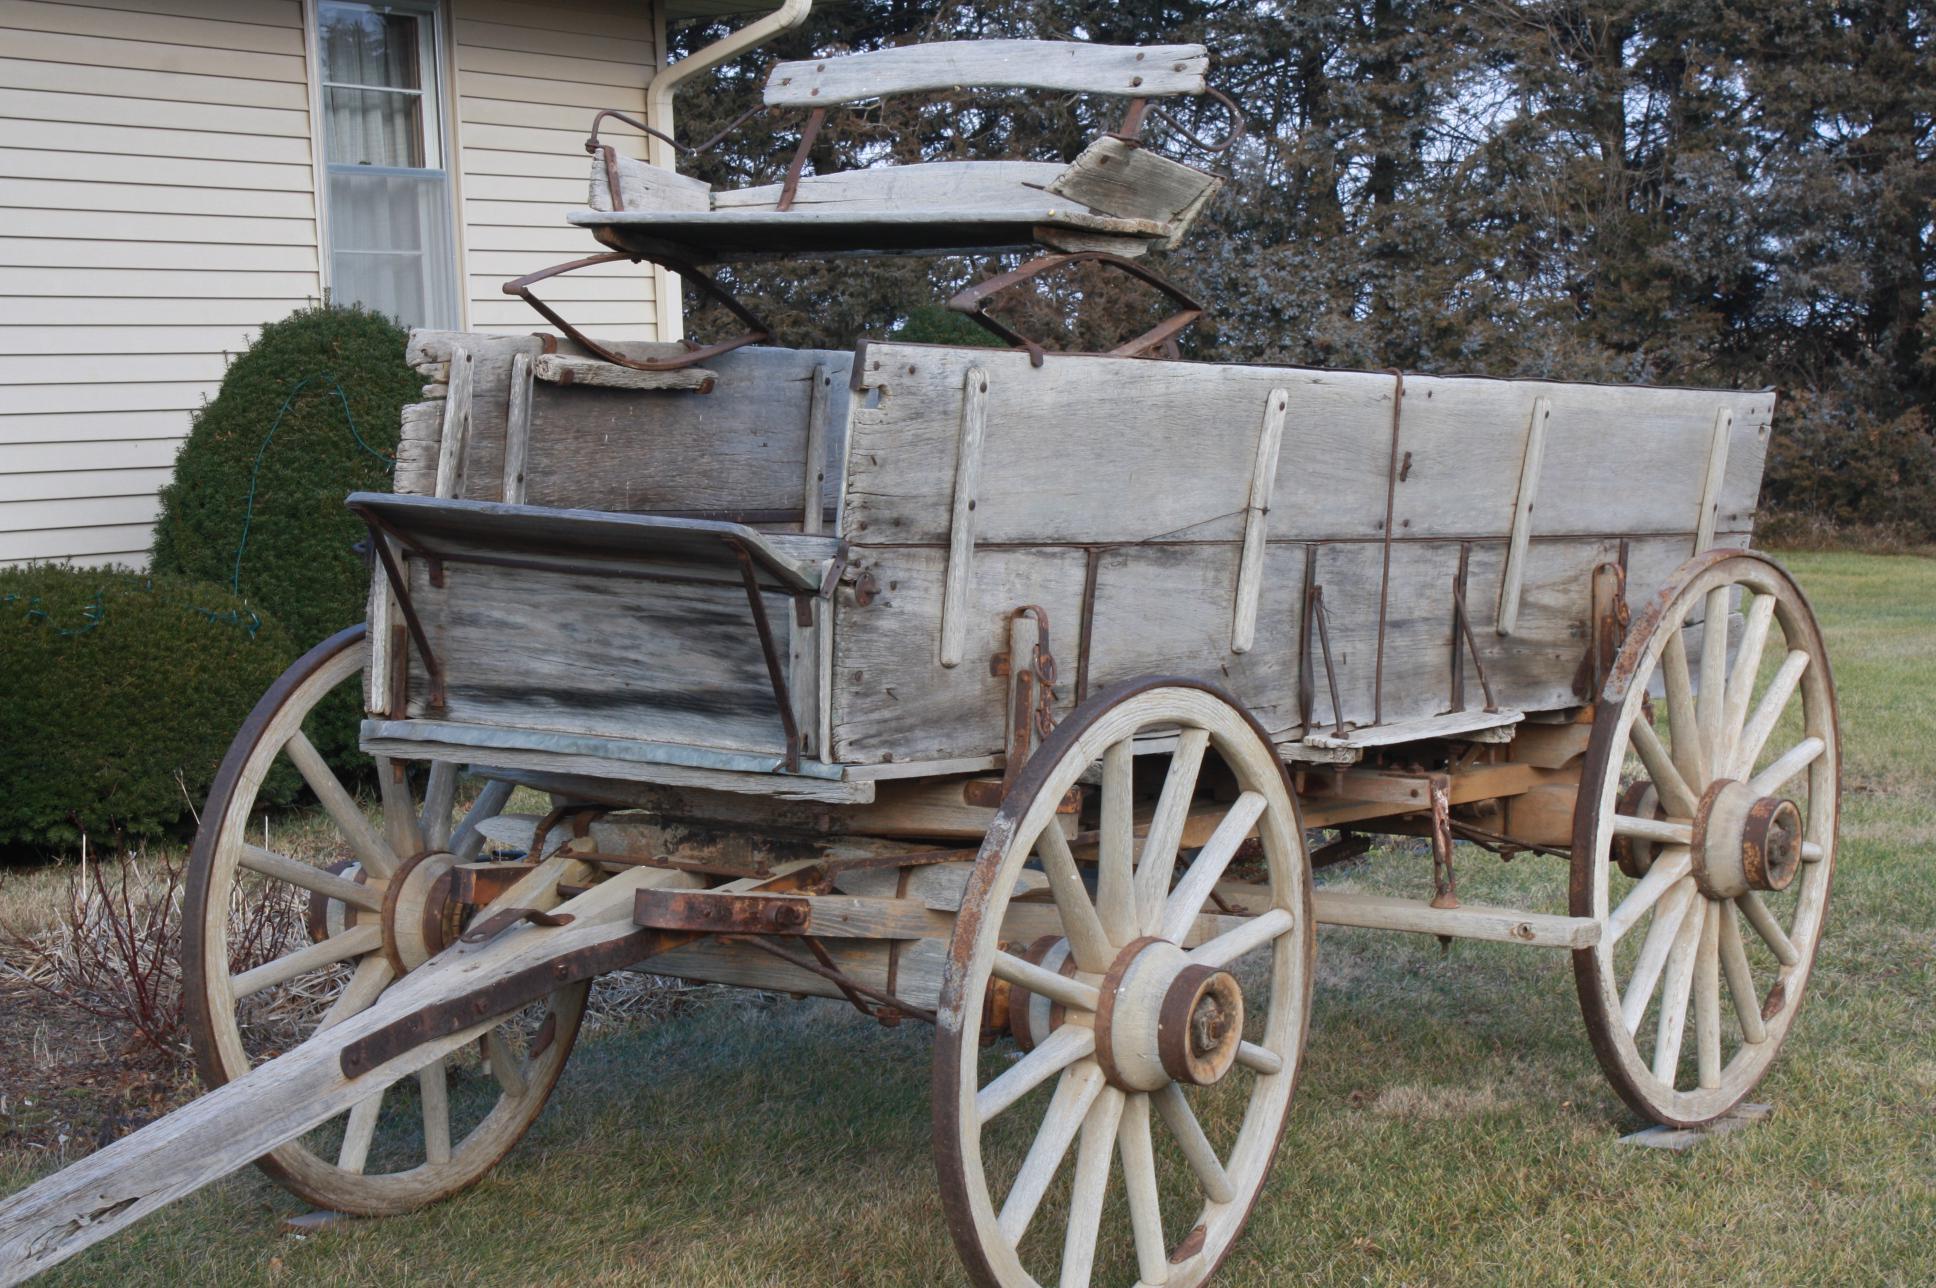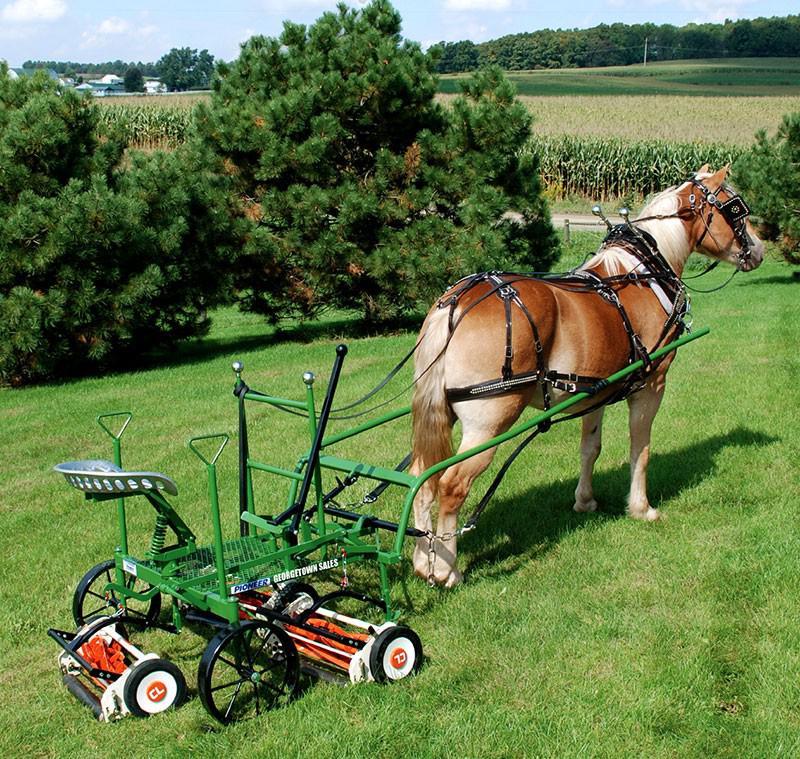The first image is the image on the left, the second image is the image on the right. Examine the images to the left and right. Is the description "There is a picture showing a horse hitched up to a piece of equipment." accurate? Answer yes or no. Yes. The first image is the image on the left, the second image is the image on the right. Assess this claim about the two images: "An image shows a brown horse harnessed to pull some type of wheeled thing.". Correct or not? Answer yes or no. Yes. 